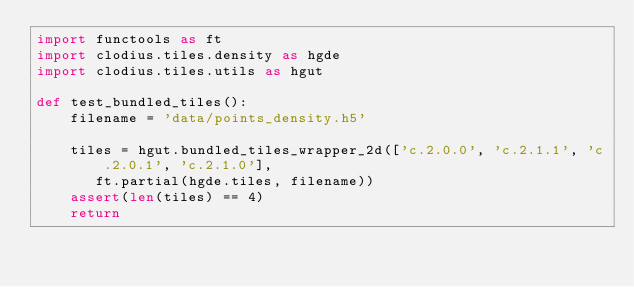Convert code to text. <code><loc_0><loc_0><loc_500><loc_500><_Python_>import functools as ft
import clodius.tiles.density as hgde 
import clodius.tiles.utils as hgut 

def test_bundled_tiles():
    filename = 'data/points_density.h5'

    tiles = hgut.bundled_tiles_wrapper_2d(['c.2.0.0', 'c.2.1.1', 'c.2.0.1', 'c.2.1.0'],
       ft.partial(hgde.tiles, filename)) 
    assert(len(tiles) == 4)
    return
</code> 